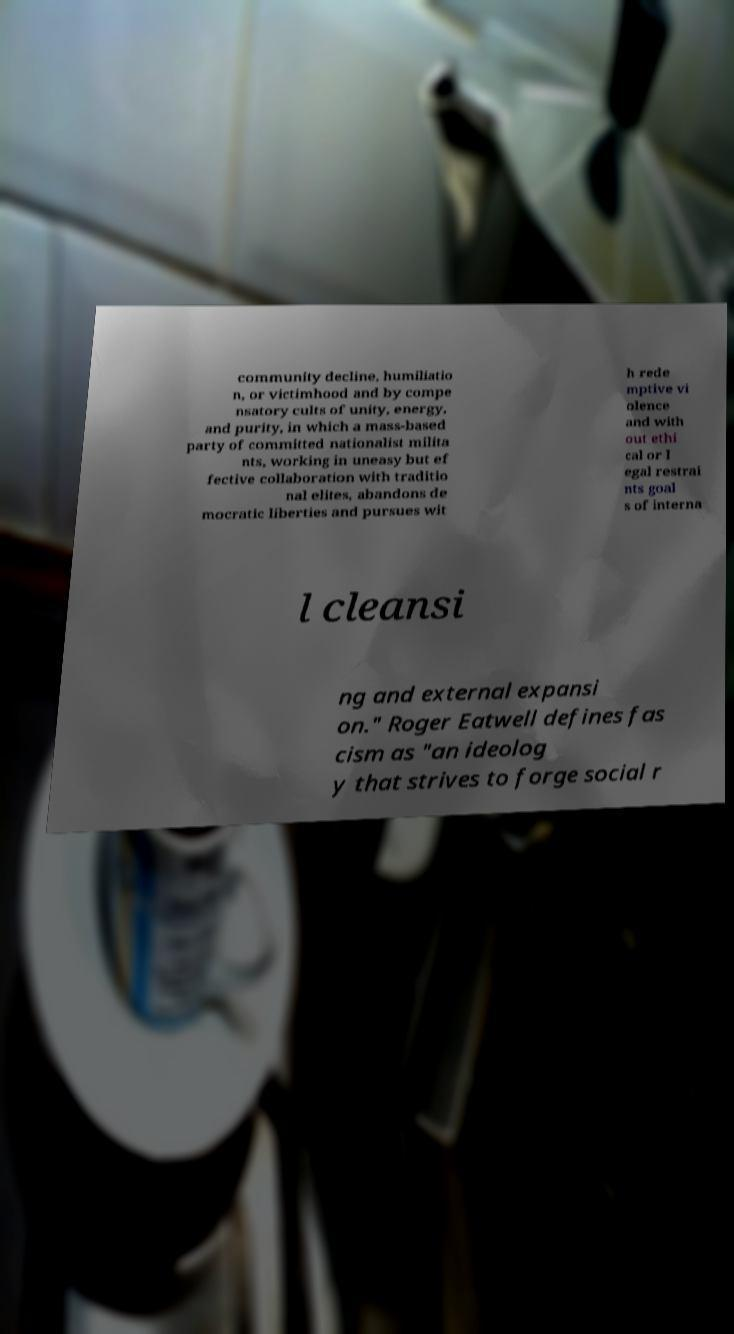For documentation purposes, I need the text within this image transcribed. Could you provide that? community decline, humiliatio n, or victimhood and by compe nsatory cults of unity, energy, and purity, in which a mass-based party of committed nationalist milita nts, working in uneasy but ef fective collaboration with traditio nal elites, abandons de mocratic liberties and pursues wit h rede mptive vi olence and with out ethi cal or l egal restrai nts goal s of interna l cleansi ng and external expansi on." Roger Eatwell defines fas cism as "an ideolog y that strives to forge social r 